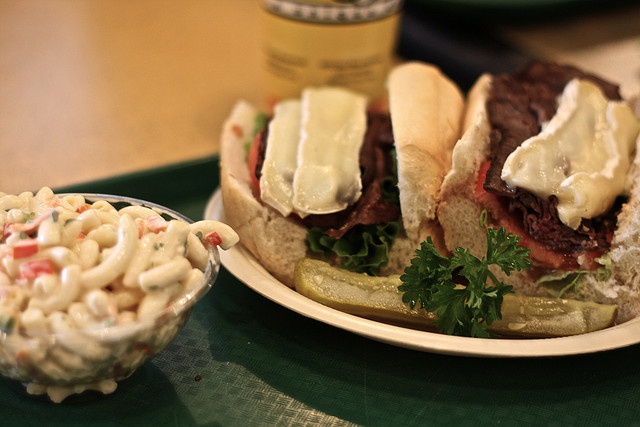Describe the objects in this image and their specific colors. I can see sandwich in tan and black tones, sandwich in tan, maroon, black, and olive tones, bowl in tan tones, bowl in tan, black, and maroon tones, and cup in tan, olive, and orange tones in this image. 